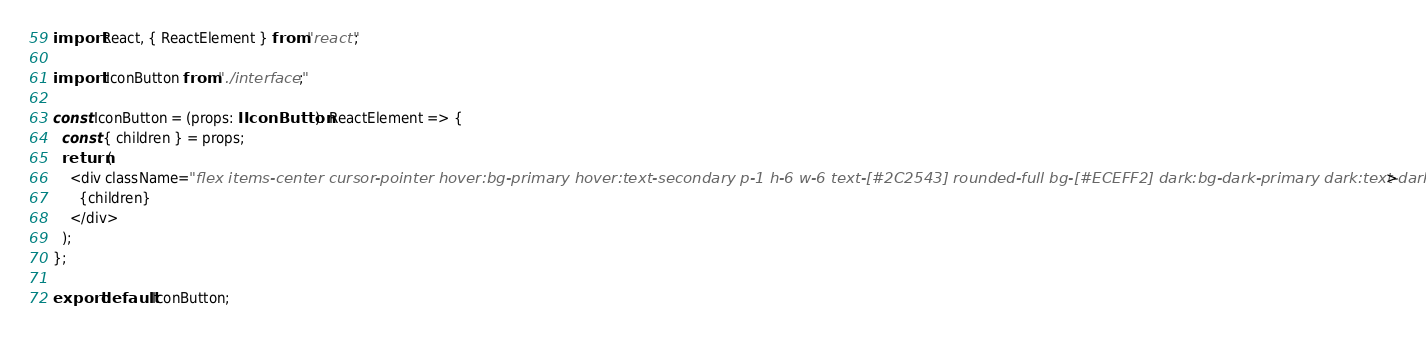Convert code to text. <code><loc_0><loc_0><loc_500><loc_500><_TypeScript_>import React, { ReactElement } from "react";

import IIconButton from "./interface";

const IconButton = (props: IIconButton): ReactElement => {
  const { children } = props;
  return (
    <div className="flex items-center cursor-pointer hover:bg-primary hover:text-secondary p-1 h-6 w-6 text-[#2C2543] rounded-full bg-[#ECEFF2] dark:bg-dark-primary dark:text-dark-secondary">
      {children}
    </div>
  );
};

export default IconButton;
</code> 